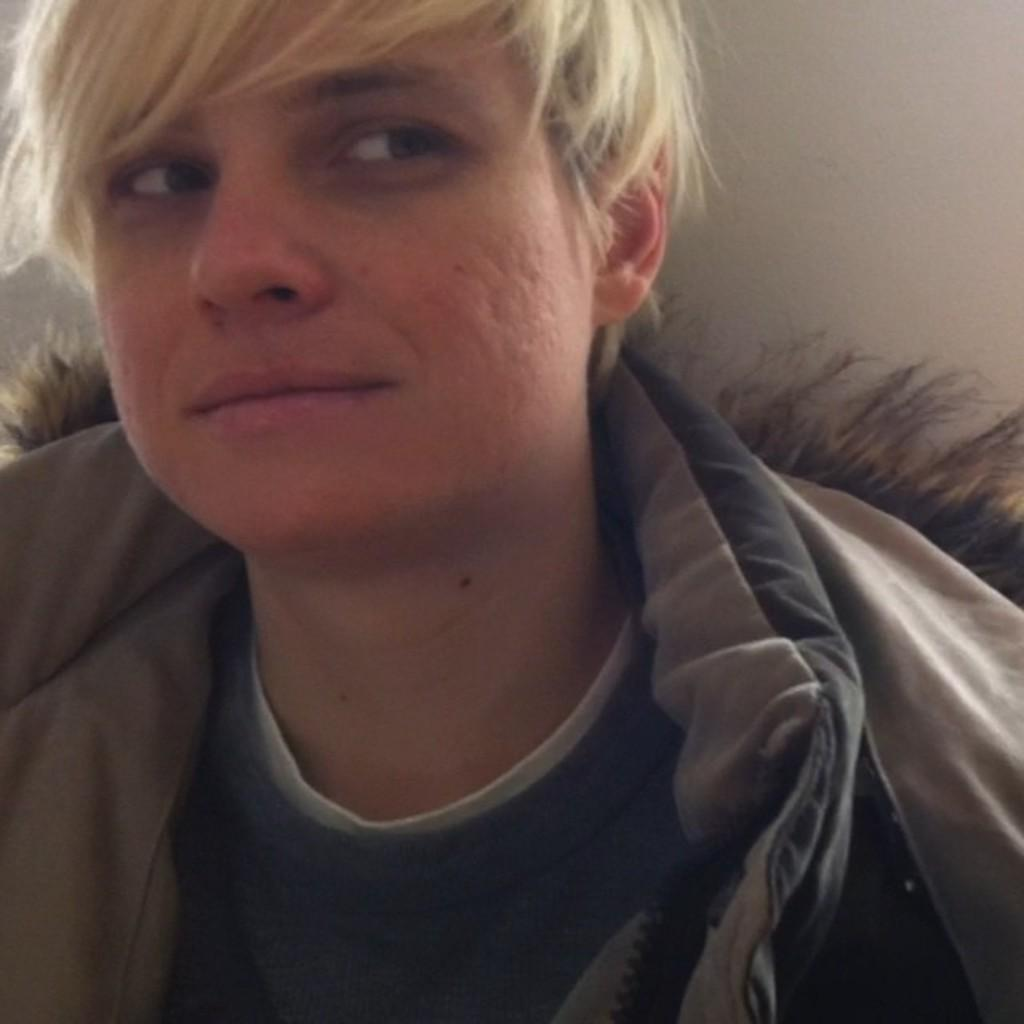What is the main subject of the image? There is a close view of a man in the image. What can be observed about the man's attire? The man is wearing clothes. What color is the background of the image? The background of the image is white. What color is the man's hair in the image? The provided facts do not mention the color of the man's hair, so it cannot be determined from the image. Can you tell me how many times the man smashes a hall in the image? There is no mention of the man smashing a hall or any other action in the image. 